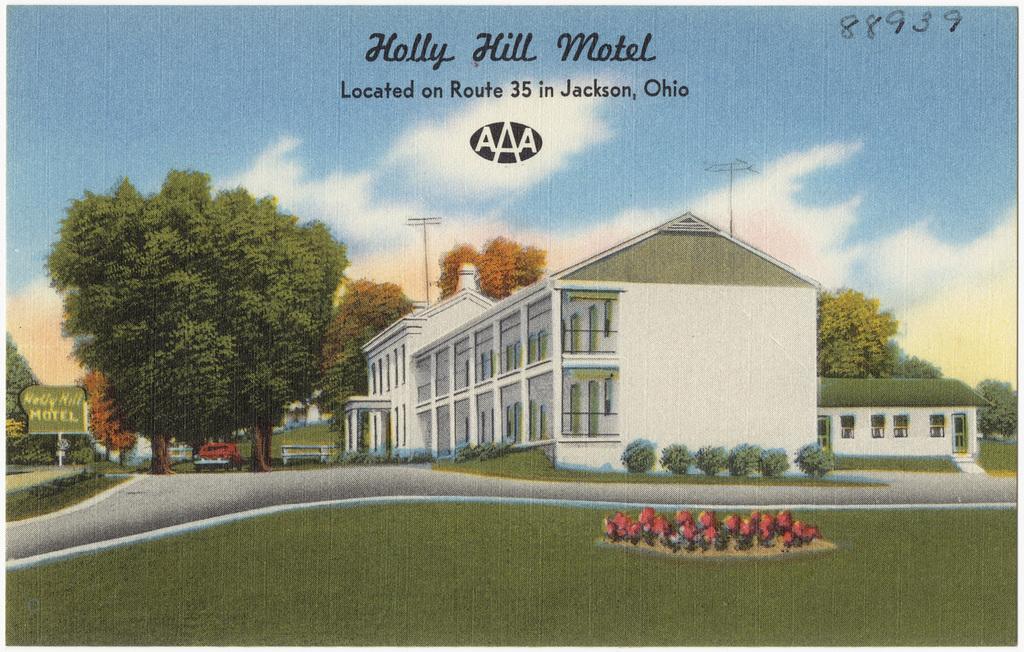Please provide a concise description of this image. In this image we can see a few houses, there are some trees, poles, flowers, plants, grass, pillars, windows, board and a vehicle, in the background we can see the sky with clouds. 